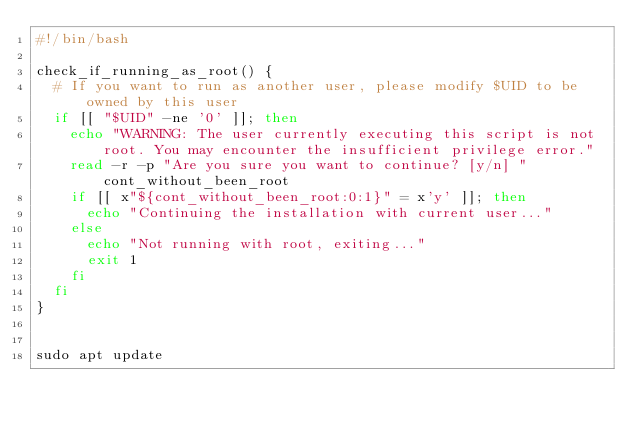Convert code to text. <code><loc_0><loc_0><loc_500><loc_500><_Bash_>#!/bin/bash

check_if_running_as_root() {
  # If you want to run as another user, please modify $UID to be owned by this user
  if [[ "$UID" -ne '0' ]]; then
    echo "WARNING: The user currently executing this script is not root. You may encounter the insufficient privilege error."
    read -r -p "Are you sure you want to continue? [y/n] " cont_without_been_root
    if [[ x"${cont_without_been_root:0:1}" = x'y' ]]; then
      echo "Continuing the installation with current user..."
    else
      echo "Not running with root, exiting..."
      exit 1
    fi
  fi
}


sudo apt update
</code> 